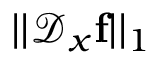<formula> <loc_0><loc_0><loc_500><loc_500>| | \mathcal { D } _ { x } f | | _ { 1 }</formula> 